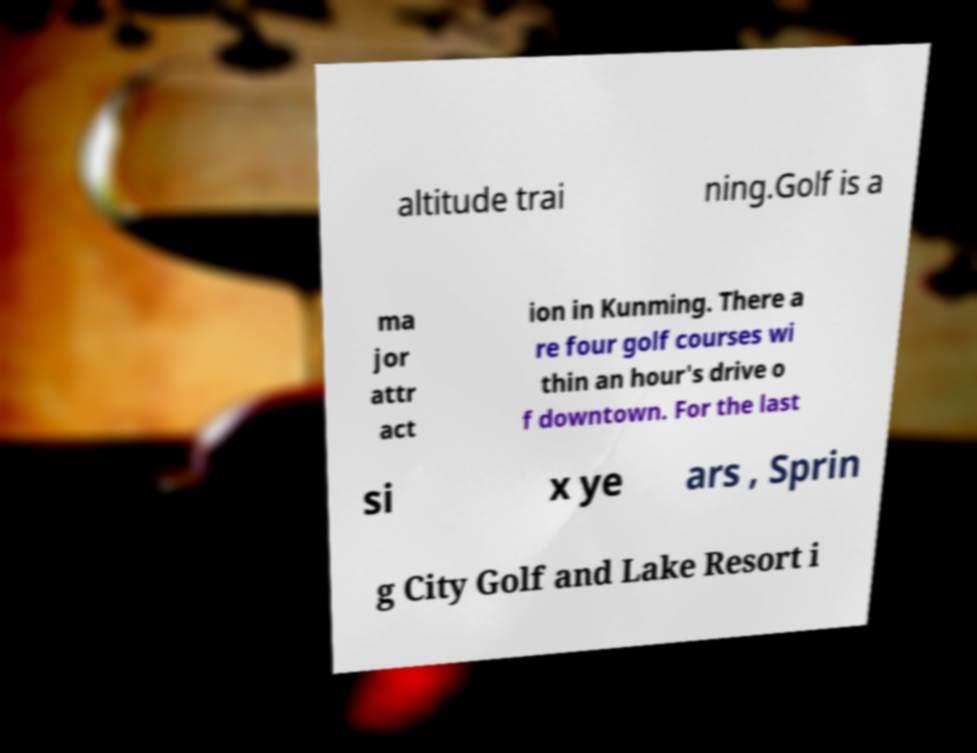There's text embedded in this image that I need extracted. Can you transcribe it verbatim? altitude trai ning.Golf is a ma jor attr act ion in Kunming. There a re four golf courses wi thin an hour's drive o f downtown. For the last si x ye ars , Sprin g City Golf and Lake Resort i 